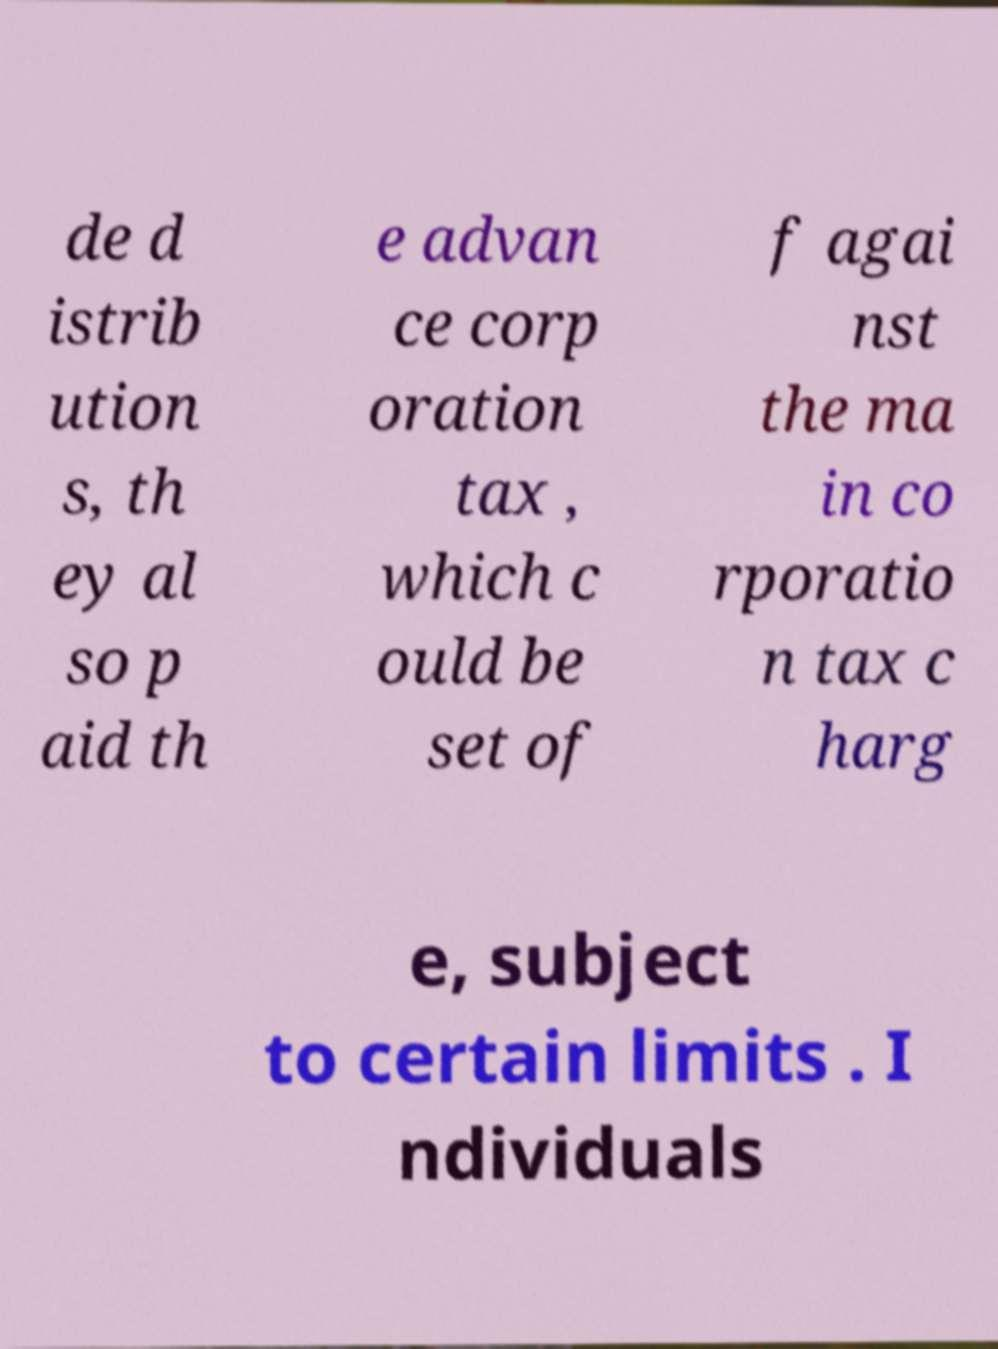Can you read and provide the text displayed in the image?This photo seems to have some interesting text. Can you extract and type it out for me? de d istrib ution s, th ey al so p aid th e advan ce corp oration tax , which c ould be set of f agai nst the ma in co rporatio n tax c harg e, subject to certain limits . I ndividuals 